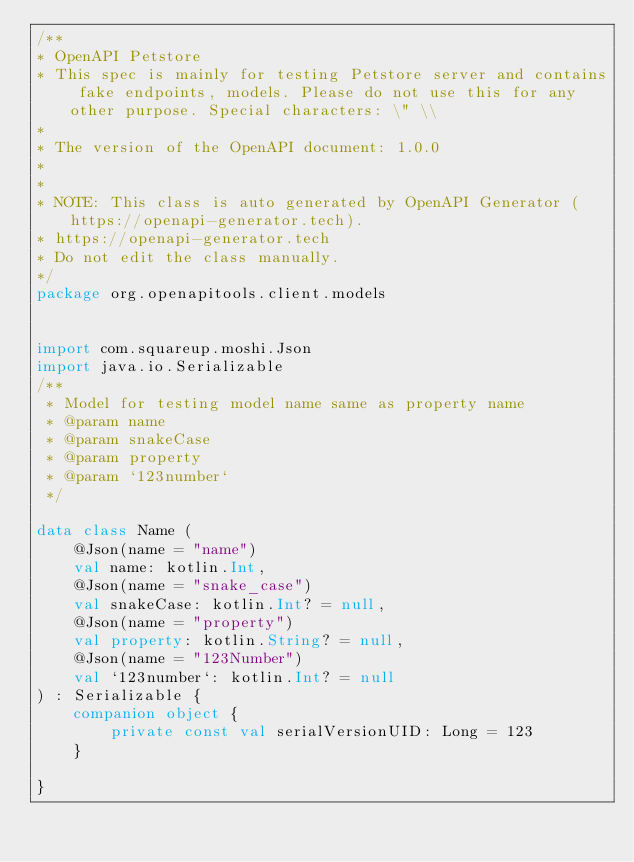Convert code to text. <code><loc_0><loc_0><loc_500><loc_500><_Kotlin_>/**
* OpenAPI Petstore
* This spec is mainly for testing Petstore server and contains fake endpoints, models. Please do not use this for any other purpose. Special characters: \" \\
*
* The version of the OpenAPI document: 1.0.0
* 
*
* NOTE: This class is auto generated by OpenAPI Generator (https://openapi-generator.tech).
* https://openapi-generator.tech
* Do not edit the class manually.
*/
package org.openapitools.client.models


import com.squareup.moshi.Json
import java.io.Serializable
/**
 * Model for testing model name same as property name
 * @param name 
 * @param snakeCase 
 * @param property 
 * @param `123number` 
 */

data class Name (
    @Json(name = "name")
    val name: kotlin.Int,
    @Json(name = "snake_case")
    val snakeCase: kotlin.Int? = null,
    @Json(name = "property")
    val property: kotlin.String? = null,
    @Json(name = "123Number")
    val `123number`: kotlin.Int? = null
) : Serializable {
    companion object {
        private const val serialVersionUID: Long = 123
    }

}

</code> 